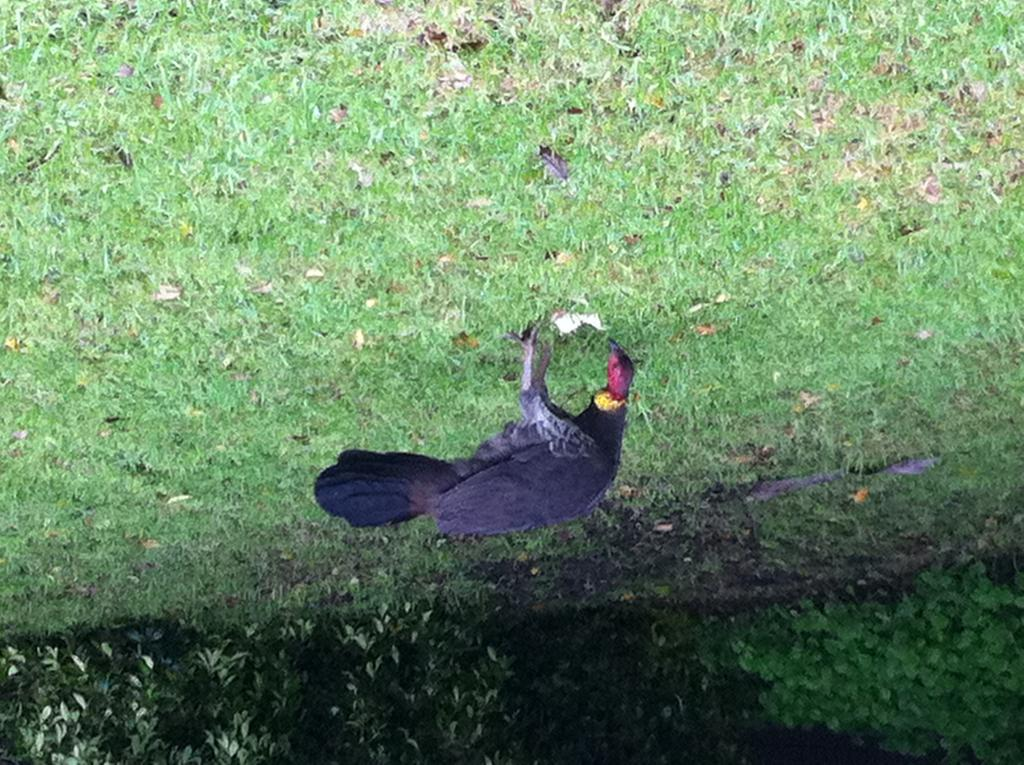What animal is present in the image? There is a hen in the image. Where is the hen located? The hen is standing on the grass. What can be seen in the background of the image? There are trees in the background of the image. What type of humor can be seen in the girl's expression in the image? There is no girl present in the image, only a hen. 